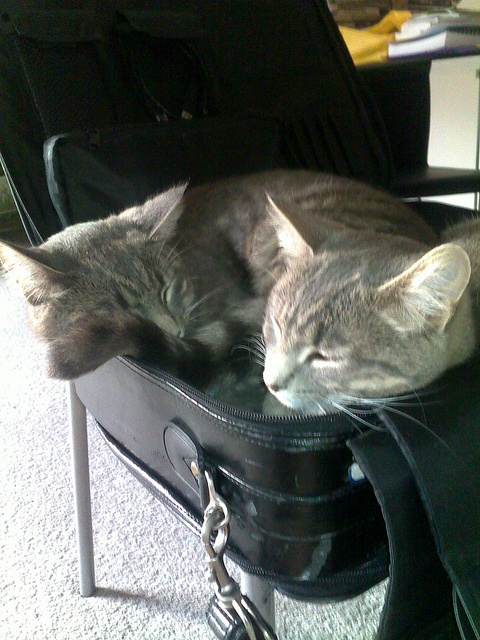Describe the objects in this image and their specific colors. I can see suitcase in black, gray, darkgray, and purple tones, cat in black, gray, and ivory tones, chair in black, gray, darkgray, and darkgreen tones, chair in black, darkgray, gray, and white tones, and book in black, lightgray, gray, and darkgray tones in this image. 